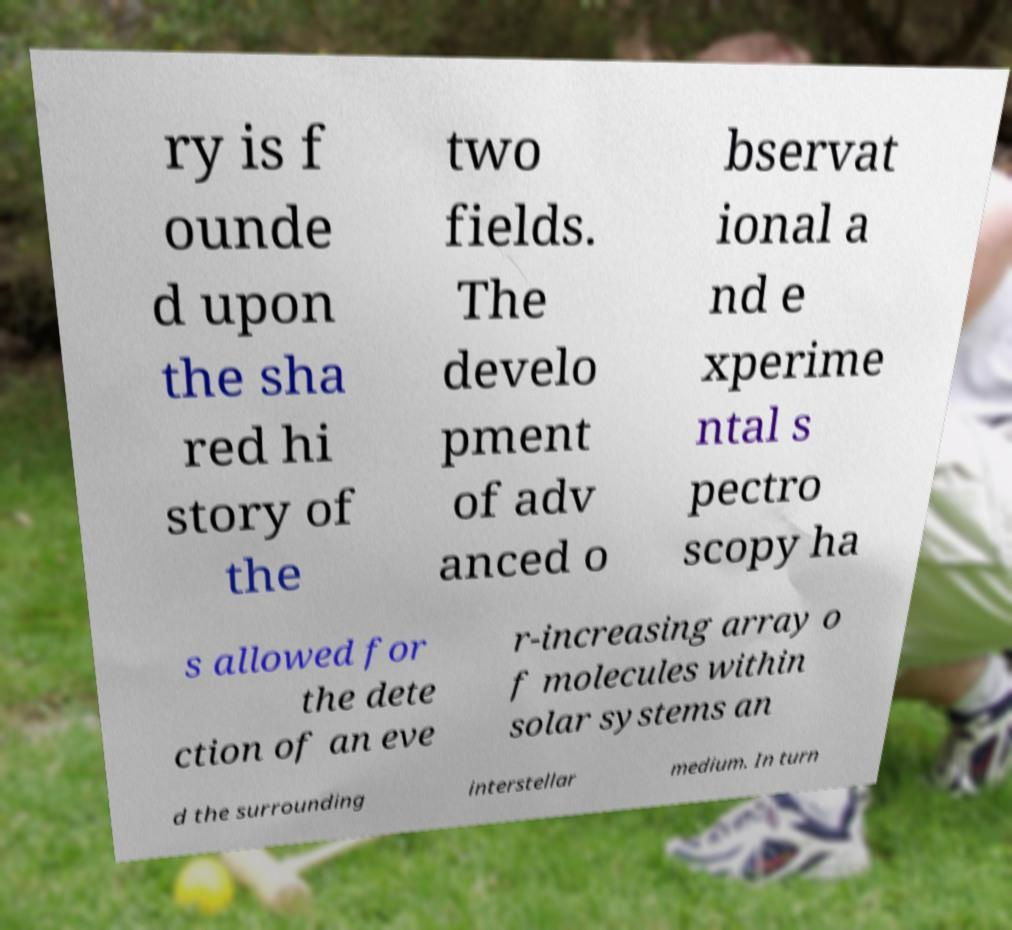Please read and relay the text visible in this image. What does it say? ry is f ounde d upon the sha red hi story of the two fields. The develo pment of adv anced o bservat ional a nd e xperime ntal s pectro scopy ha s allowed for the dete ction of an eve r-increasing array o f molecules within solar systems an d the surrounding interstellar medium. In turn 